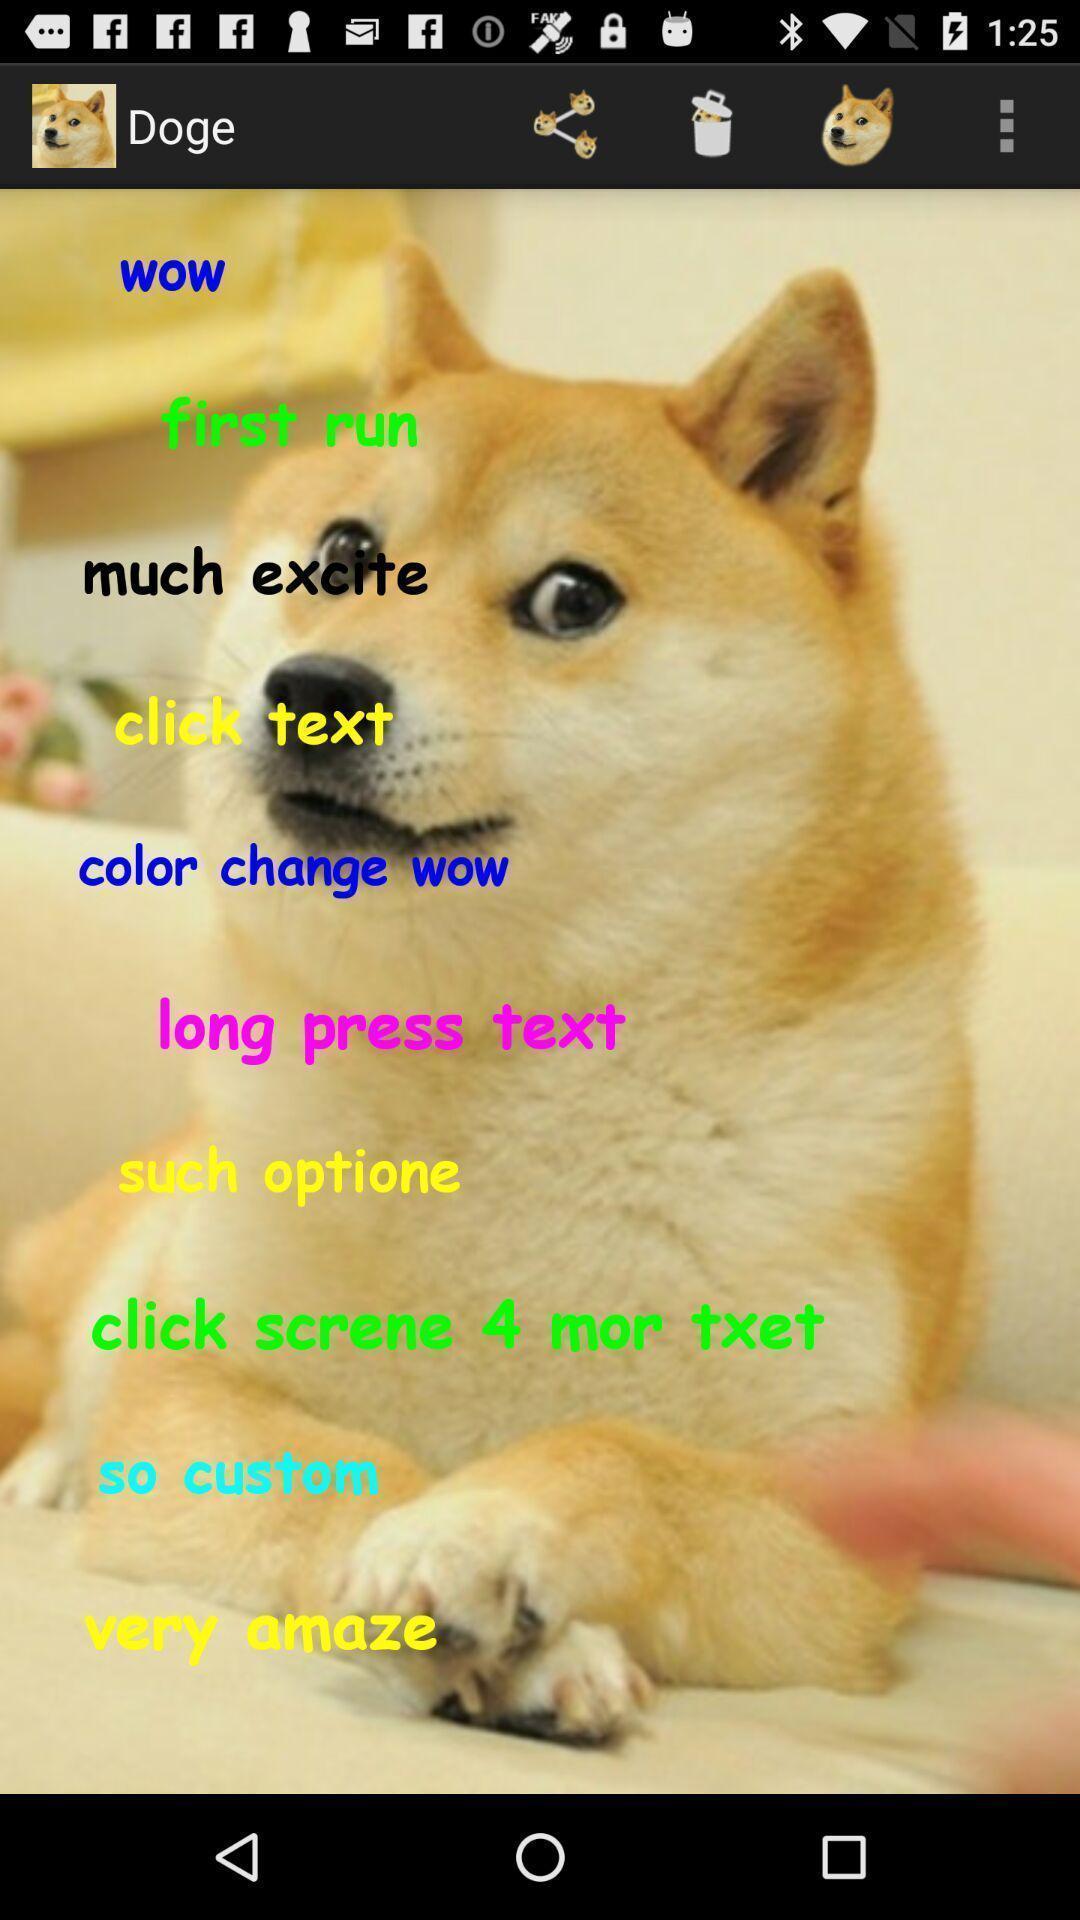Give me a summary of this screen capture. Page displaying the dog mood activity. 